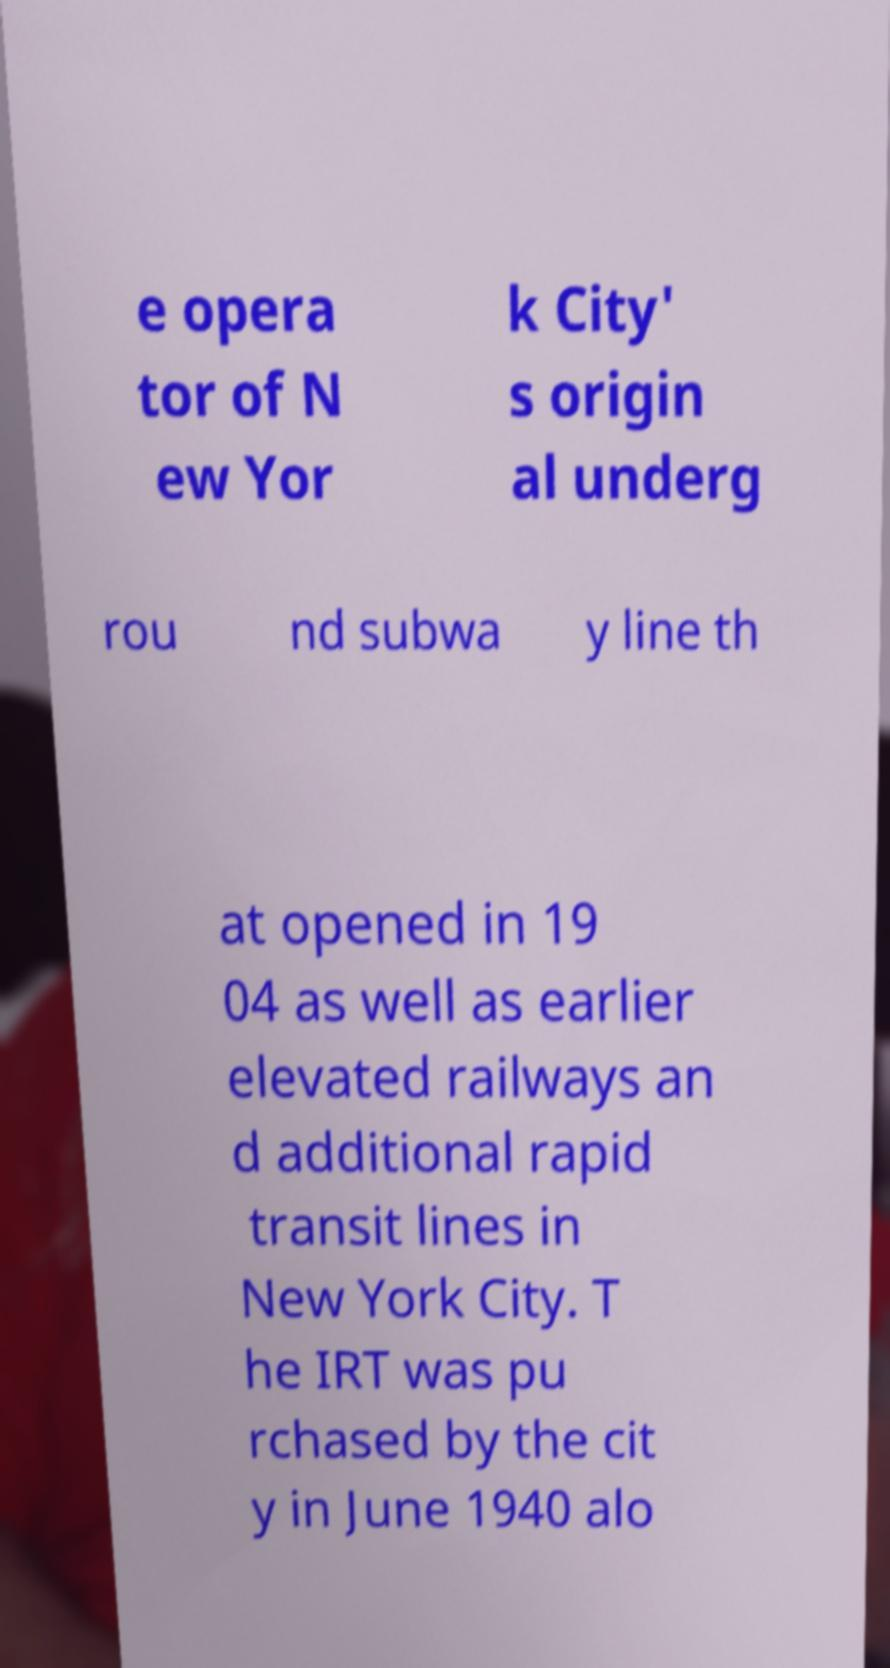There's text embedded in this image that I need extracted. Can you transcribe it verbatim? e opera tor of N ew Yor k City' s origin al underg rou nd subwa y line th at opened in 19 04 as well as earlier elevated railways an d additional rapid transit lines in New York City. T he IRT was pu rchased by the cit y in June 1940 alo 